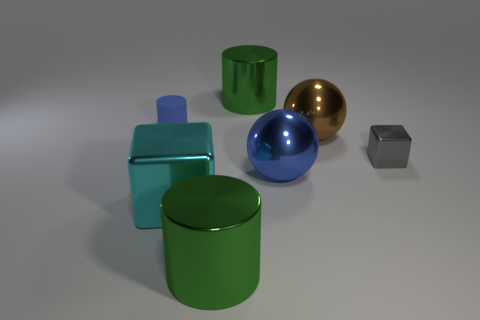Add 3 green cylinders. How many objects exist? 10 Subtract all blocks. How many objects are left? 5 Add 1 cylinders. How many cylinders are left? 4 Add 5 green shiny balls. How many green shiny balls exist? 5 Subtract 0 purple cubes. How many objects are left? 7 Subtract all big purple rubber cubes. Subtract all big blue shiny objects. How many objects are left? 6 